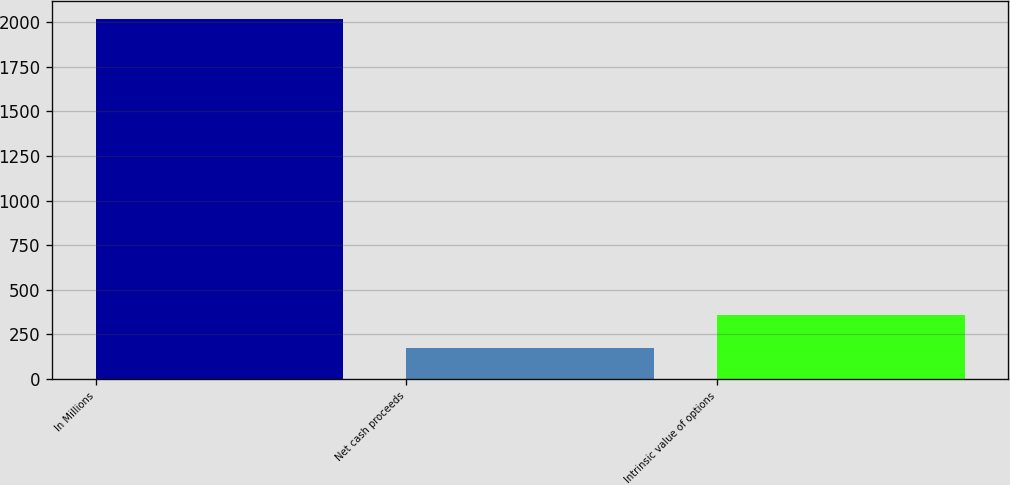Convert chart to OTSL. <chart><loc_0><loc_0><loc_500><loc_500><bar_chart><fcel>In Millions<fcel>Net cash proceeds<fcel>Intrinsic value of options<nl><fcel>2016<fcel>171.9<fcel>356.31<nl></chart> 